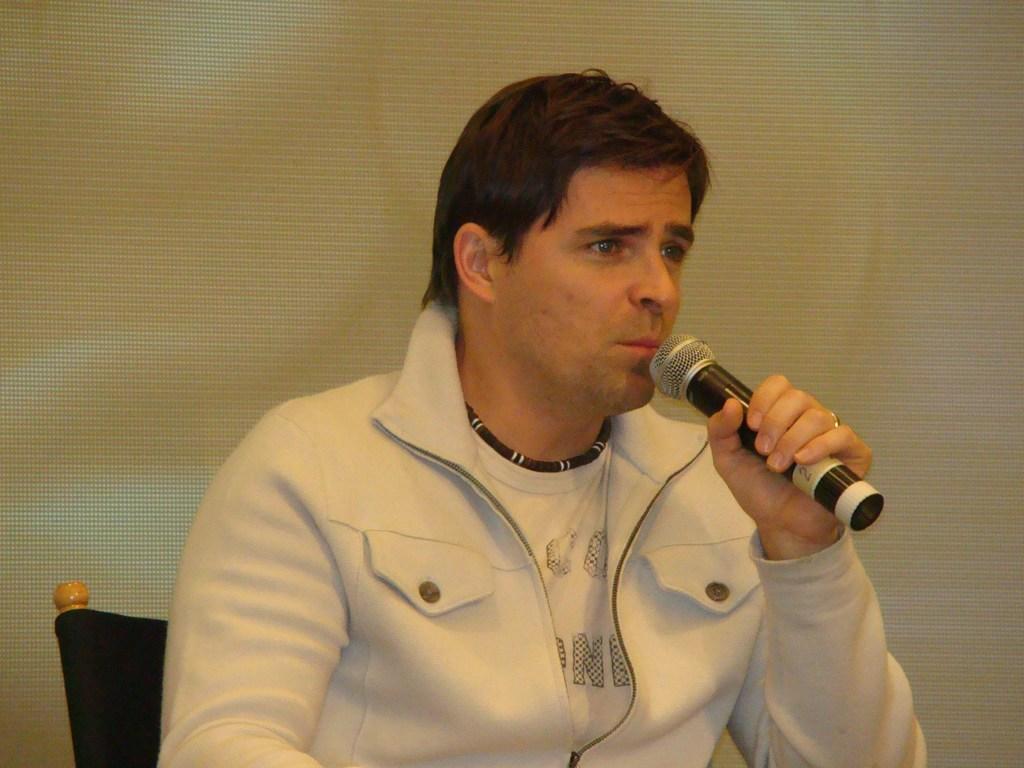Could you give a brief overview of what you see in this image? In this picture ,a man is sitting in a chair and talking with a mic in his hand. 